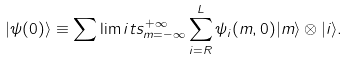Convert formula to latex. <formula><loc_0><loc_0><loc_500><loc_500>| \psi ( 0 ) \rangle \equiv \sum \lim i t s _ { m = - \infty } ^ { + \infty } \sum _ { i = R } ^ { L } \psi _ { i } ( m , 0 ) | m \rangle \otimes | i \rangle .</formula> 